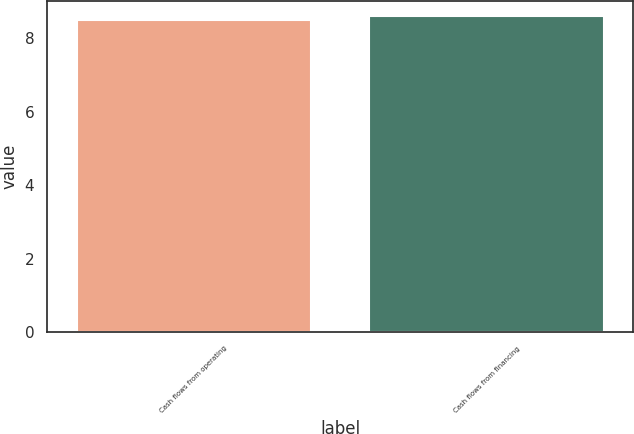Convert chart to OTSL. <chart><loc_0><loc_0><loc_500><loc_500><bar_chart><fcel>Cash flows from operating<fcel>Cash flows from financing<nl><fcel>8.5<fcel>8.6<nl></chart> 